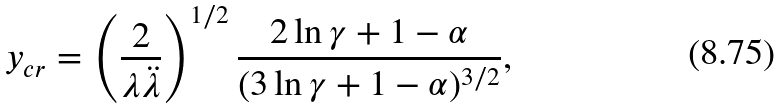Convert formula to latex. <formula><loc_0><loc_0><loc_500><loc_500>y _ { c r } = \left ( \frac { 2 } { \lambda \ddot { \lambda } } \right ) ^ { 1 / 2 } \frac { 2 \ln \gamma + 1 - \alpha } { ( 3 \ln \gamma + 1 - \alpha ) ^ { 3 / 2 } } ,</formula> 